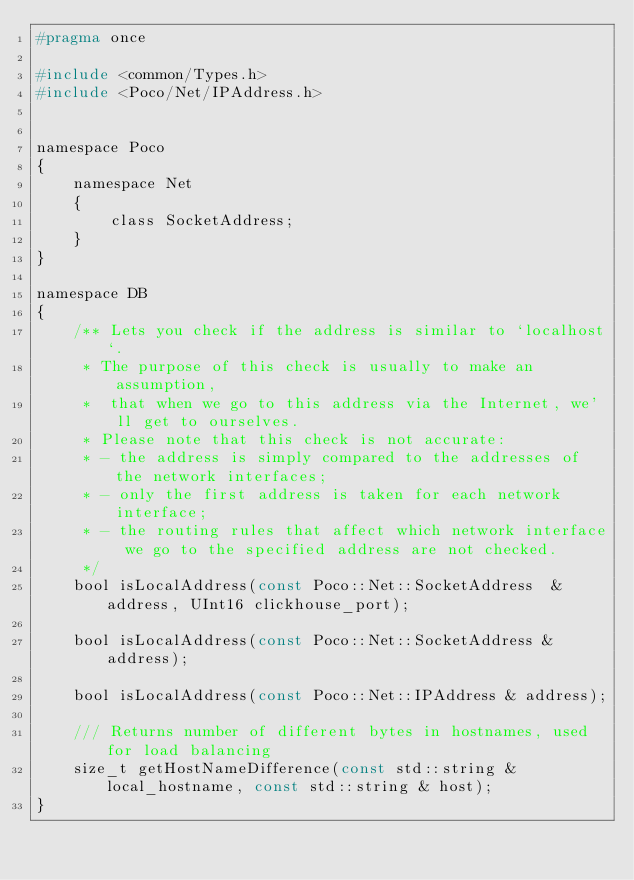Convert code to text. <code><loc_0><loc_0><loc_500><loc_500><_C_>#pragma once

#include <common/Types.h>
#include <Poco/Net/IPAddress.h>


namespace Poco
{
    namespace Net
    {
        class SocketAddress;
    }
}

namespace DB
{
    /** Lets you check if the address is similar to `localhost`.
     * The purpose of this check is usually to make an assumption,
     *  that when we go to this address via the Internet, we'll get to ourselves.
     * Please note that this check is not accurate:
     * - the address is simply compared to the addresses of the network interfaces;
     * - only the first address is taken for each network interface;
     * - the routing rules that affect which network interface we go to the specified address are not checked.
     */
    bool isLocalAddress(const Poco::Net::SocketAddress  & address, UInt16 clickhouse_port);

    bool isLocalAddress(const Poco::Net::SocketAddress & address);

    bool isLocalAddress(const Poco::Net::IPAddress & address);

    /// Returns number of different bytes in hostnames, used for load balancing
    size_t getHostNameDifference(const std::string & local_hostname, const std::string & host);
}
</code> 